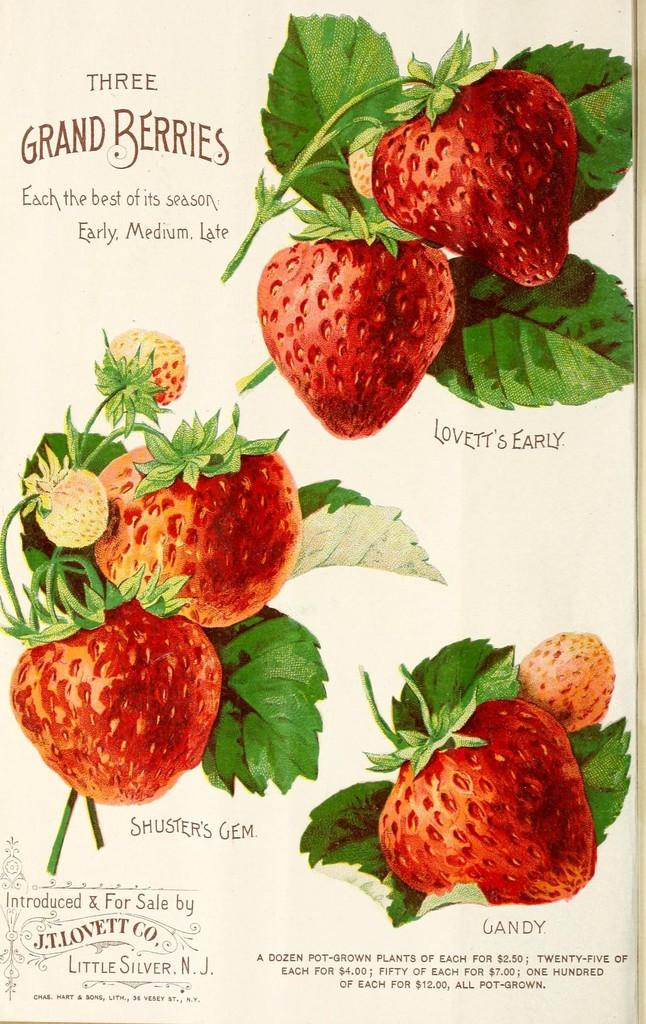What is depicted on the page in the image? A: There is a page of a book in the image, featuring strawberries and leaves. What else can be seen on the page? There is text printed on the page. What type of silk is used to create the strawberries on the page? There is no silk used to create the strawberries on the page; they are depicted as part of the illustration. 